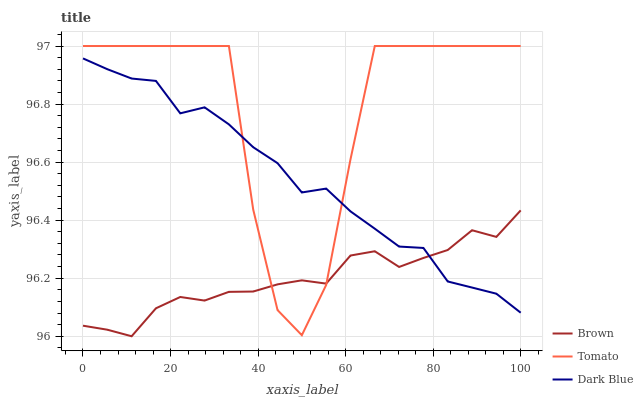Does Brown have the minimum area under the curve?
Answer yes or no. Yes. Does Tomato have the maximum area under the curve?
Answer yes or no. Yes. Does Dark Blue have the minimum area under the curve?
Answer yes or no. No. Does Dark Blue have the maximum area under the curve?
Answer yes or no. No. Is Brown the smoothest?
Answer yes or no. Yes. Is Tomato the roughest?
Answer yes or no. Yes. Is Dark Blue the smoothest?
Answer yes or no. No. Is Dark Blue the roughest?
Answer yes or no. No. Does Brown have the lowest value?
Answer yes or no. Yes. Does Dark Blue have the lowest value?
Answer yes or no. No. Does Tomato have the highest value?
Answer yes or no. Yes. Does Dark Blue have the highest value?
Answer yes or no. No. Does Brown intersect Tomato?
Answer yes or no. Yes. Is Brown less than Tomato?
Answer yes or no. No. Is Brown greater than Tomato?
Answer yes or no. No. 